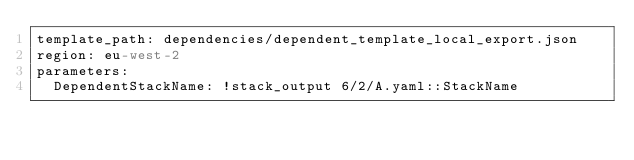<code> <loc_0><loc_0><loc_500><loc_500><_YAML_>template_path: dependencies/dependent_template_local_export.json
region: eu-west-2
parameters:
  DependentStackName: !stack_output 6/2/A.yaml::StackName
</code> 